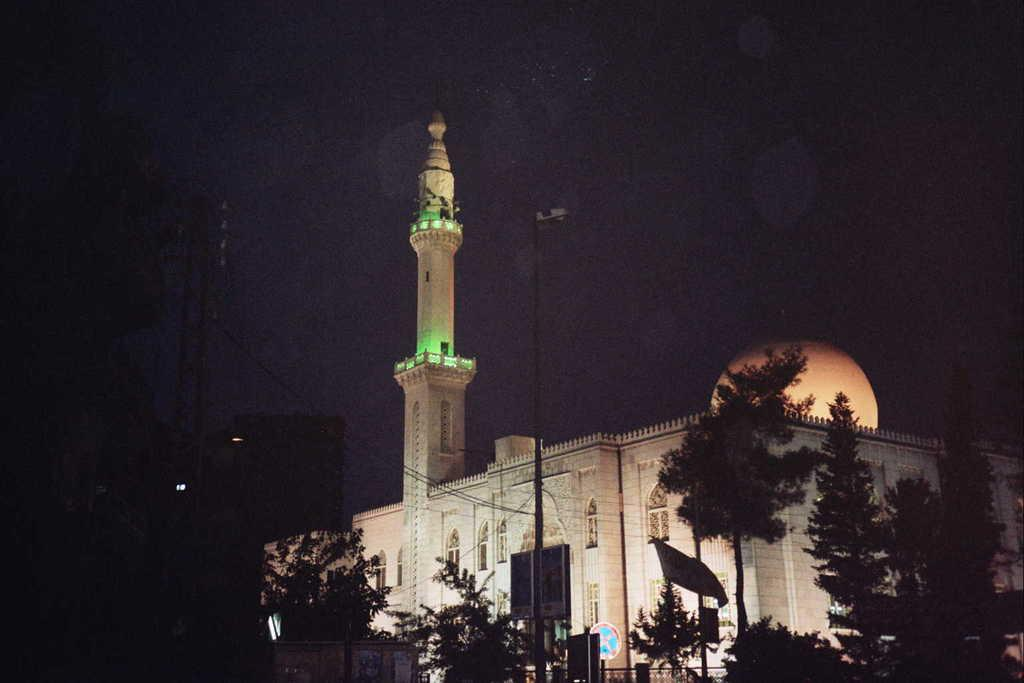What can be seen in the foreground of the image? There are trees and poles in the foreground of the image. What type of structure is visible in the image? There is a building visible in the image. What celestial body is present in the image? The moon is present in the image. How would you describe the sky in the image? The sky is dark in the image. How many cars are parked in the plantation in the image? There is no plantation or cars present in the image. Is the spy visible in the image? There is no spy present in the image. 